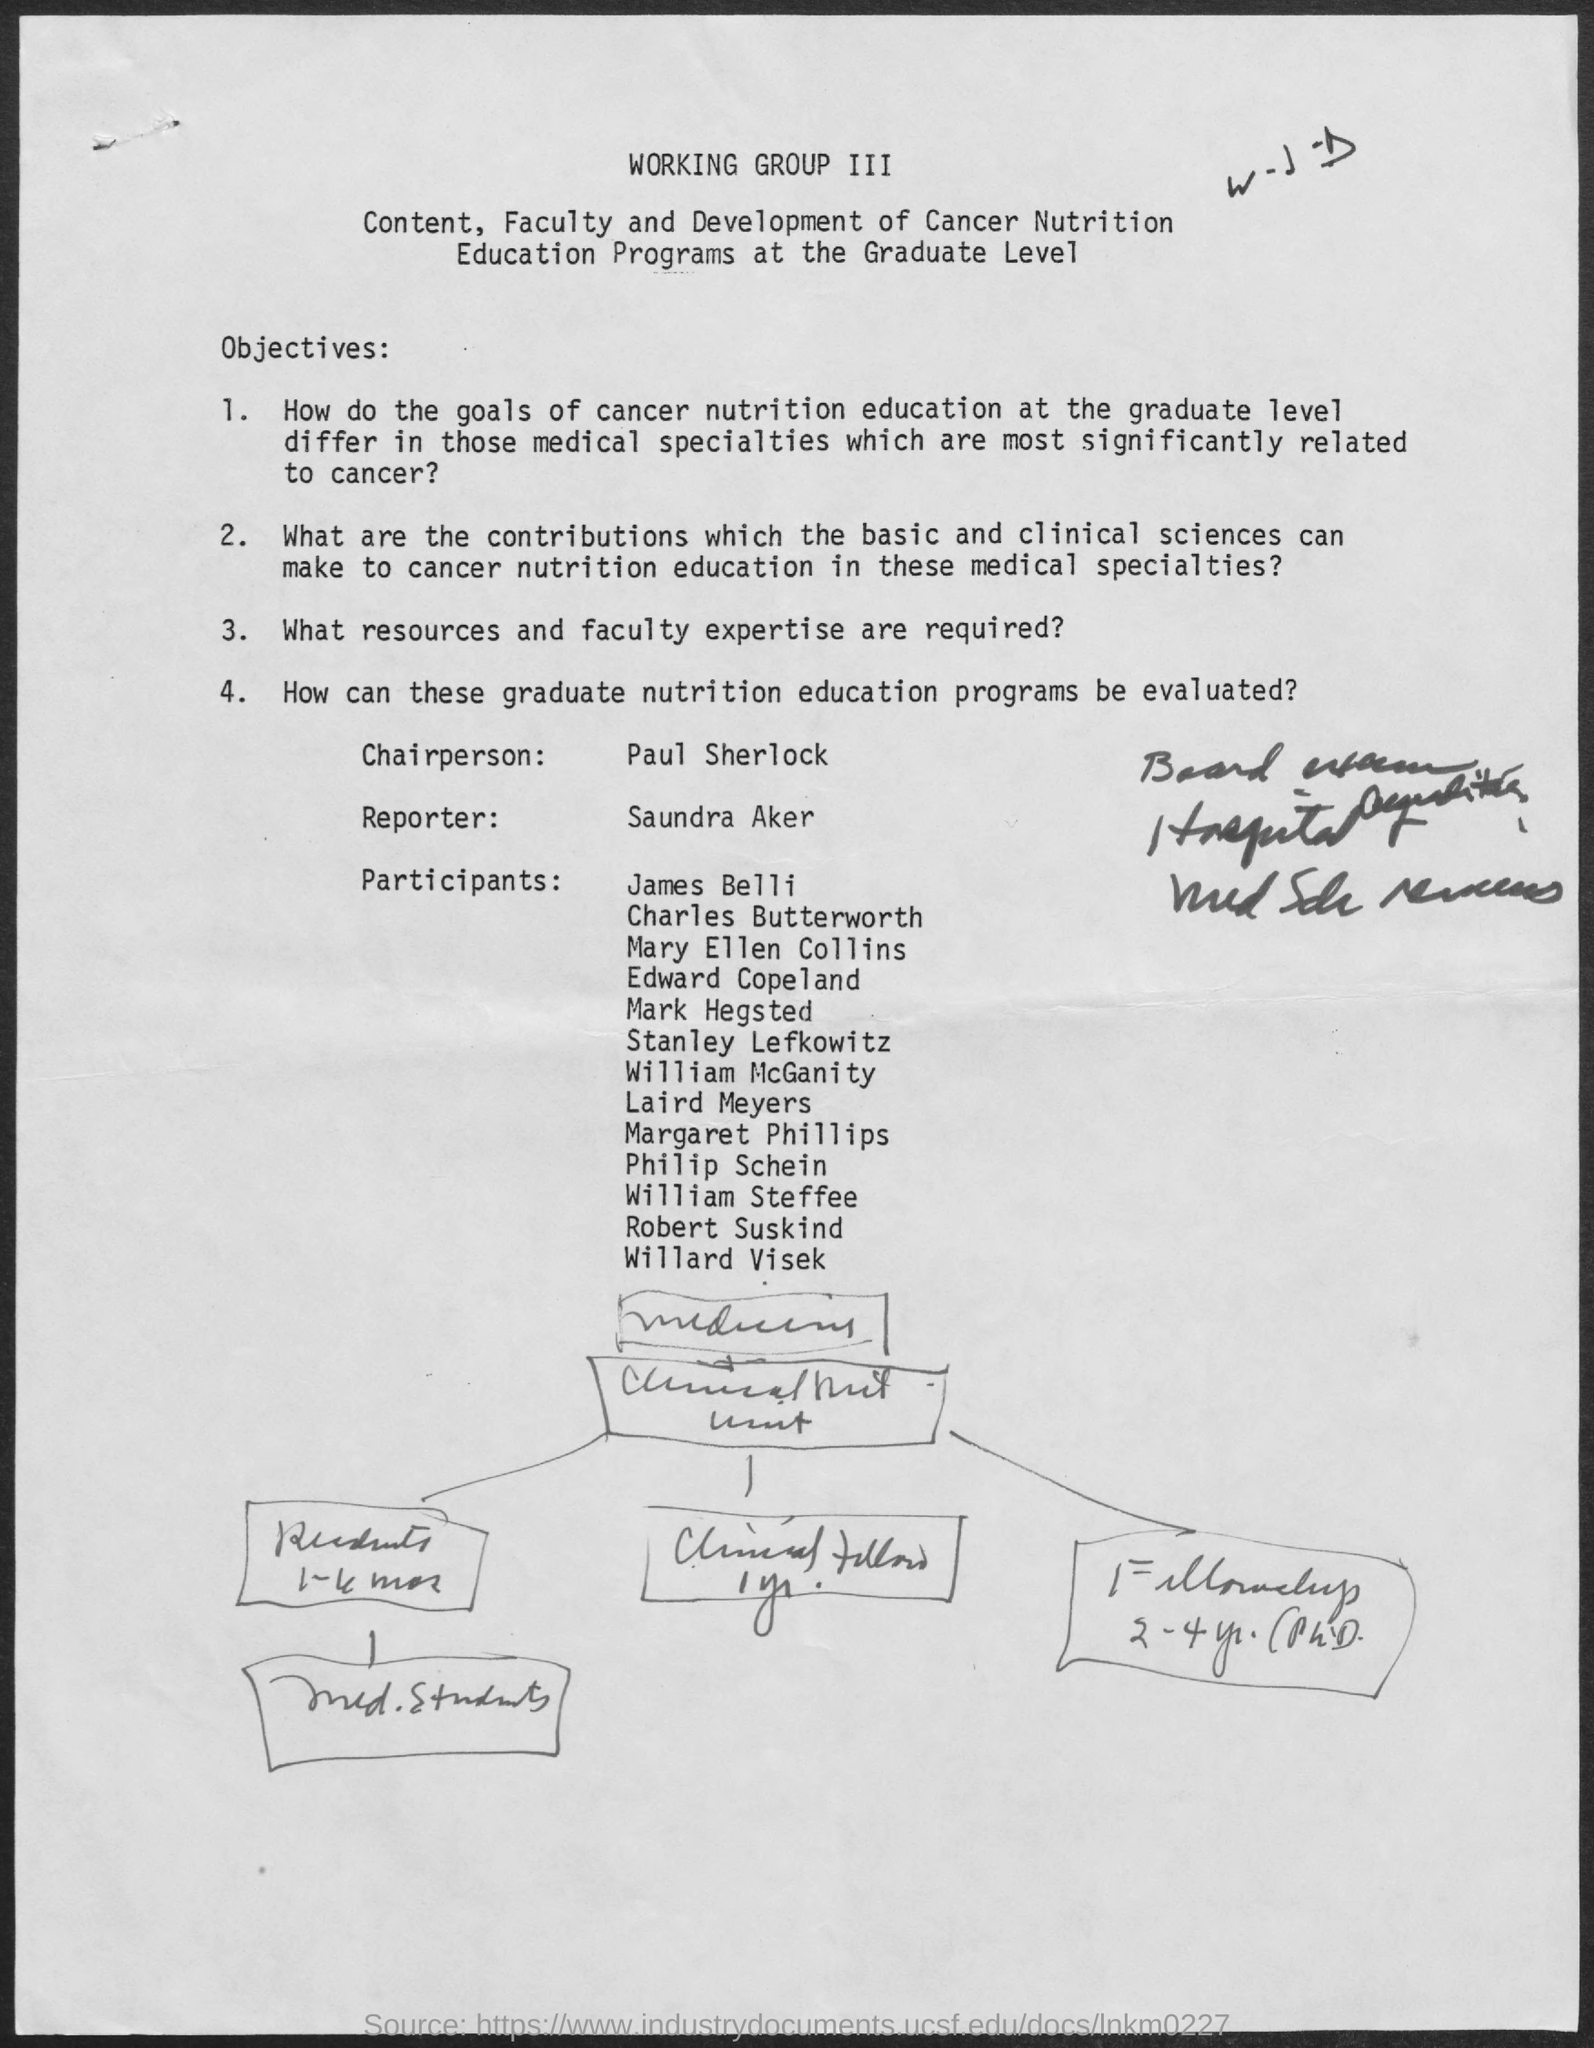Identify some key points in this picture. The reporter of this program is Saundra Aker. 